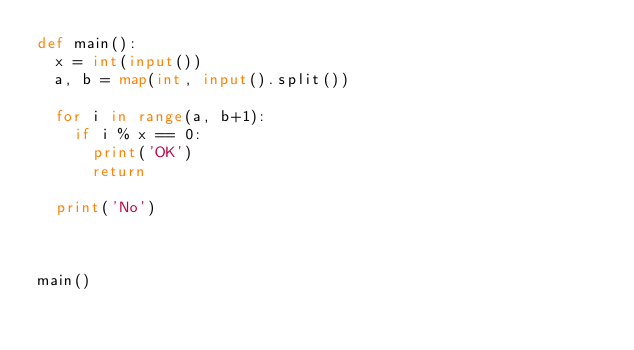<code> <loc_0><loc_0><loc_500><loc_500><_Python_>def main():
  x = int(input())
  a, b = map(int, input().split())
  
  for i in range(a, b+1):
    if i % x == 0:
      print('OK')
      return
  
  print('No')
    
      
  
main()</code> 